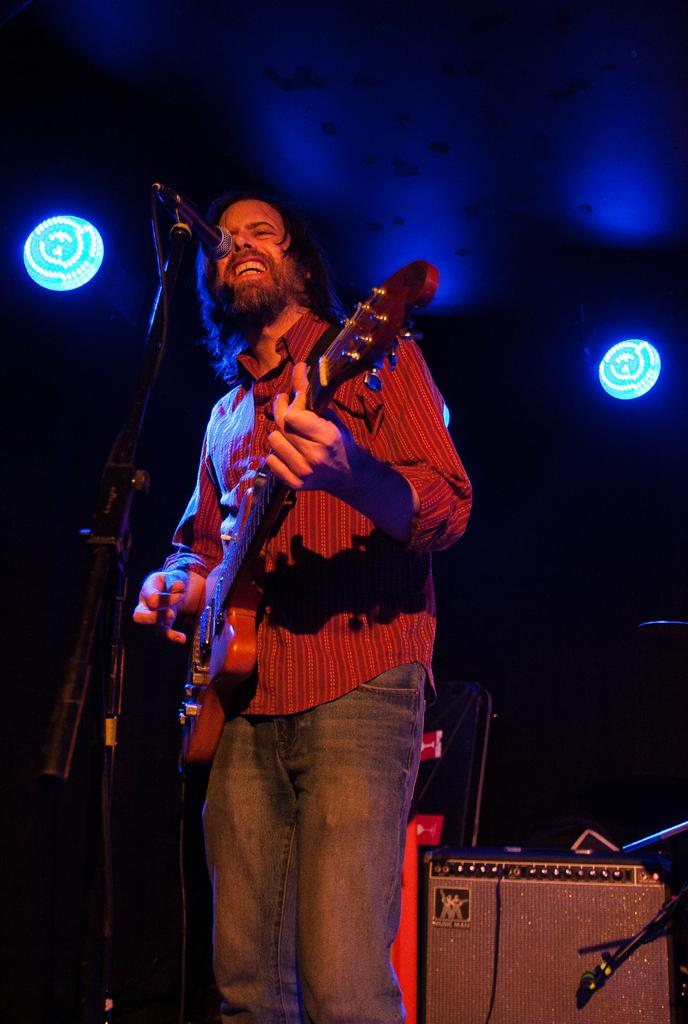What is the person in the image doing? The person is playing a guitar and singing in-front of a mic. What can be seen in the background while the person is performing? There are focusing lights and a device in the background. What type of fruit is hanging from the guitar strings in the image? There is no fruit or guitar strings present in the image; the person is playing a guitar with a mic in front of them. 